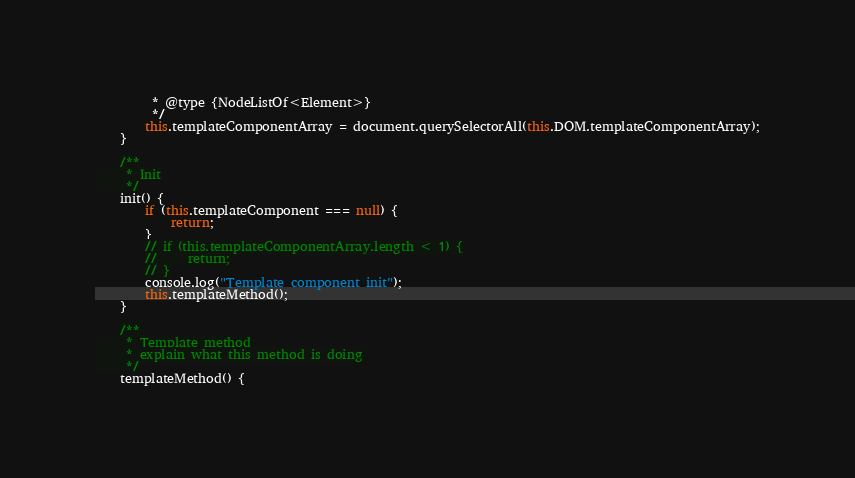Convert code to text. <code><loc_0><loc_0><loc_500><loc_500><_JavaScript_>         * @type {NodeListOf<Element>}
         */
        this.templateComponentArray = document.querySelectorAll(this.DOM.templateComponentArray);
    }

    /**
     * Init
     */
    init() {
        if (this.templateComponent === null) {
            return;
        }
        // if (this.templateComponentArray.length < 1) {
        //     return;
        // }
        console.log("Template component init");
        this.templateMethod();
    }

    /**
     * Template method
     * explain what this method is doing
     */
    templateMethod() {</code> 